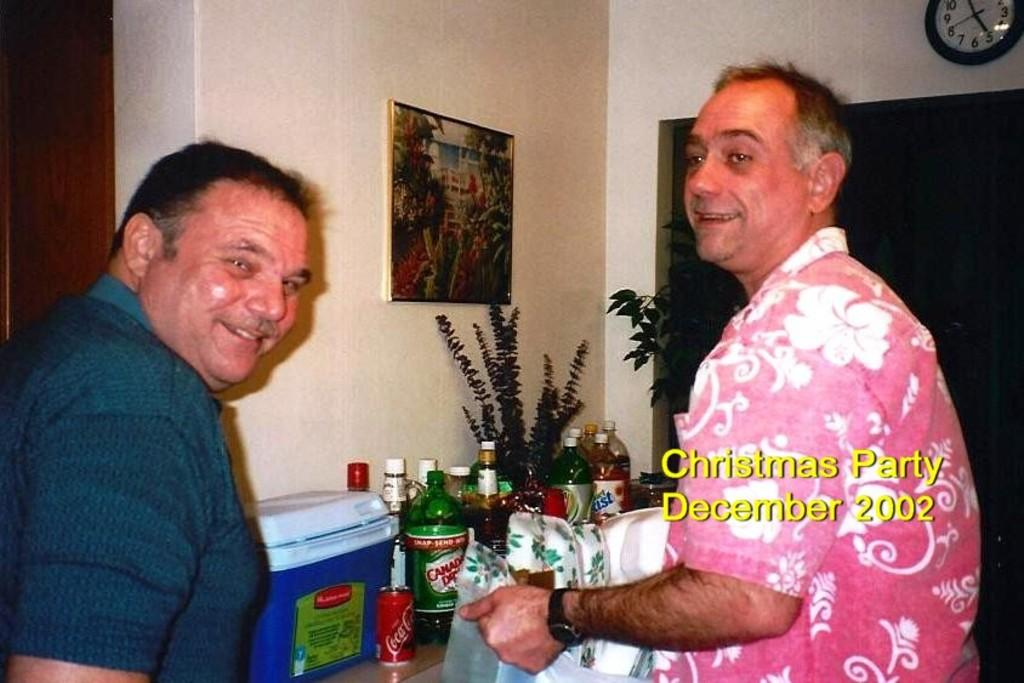How many people are in the image? There are two persons in the image. What are the two persons doing in the image? The two persons are standing. What object can be seen in the image besides the people? There is a table in the image. What items are on the table? There are drink bottles on the table. What type of self-help book is the person reading in the image? There is no person reading a book in the image; the two persons are standing. Can you tell me the name of the church located in the background of the image? There is no church or background visible in the image; it only shows two standing persons and a table with drink bottles. 